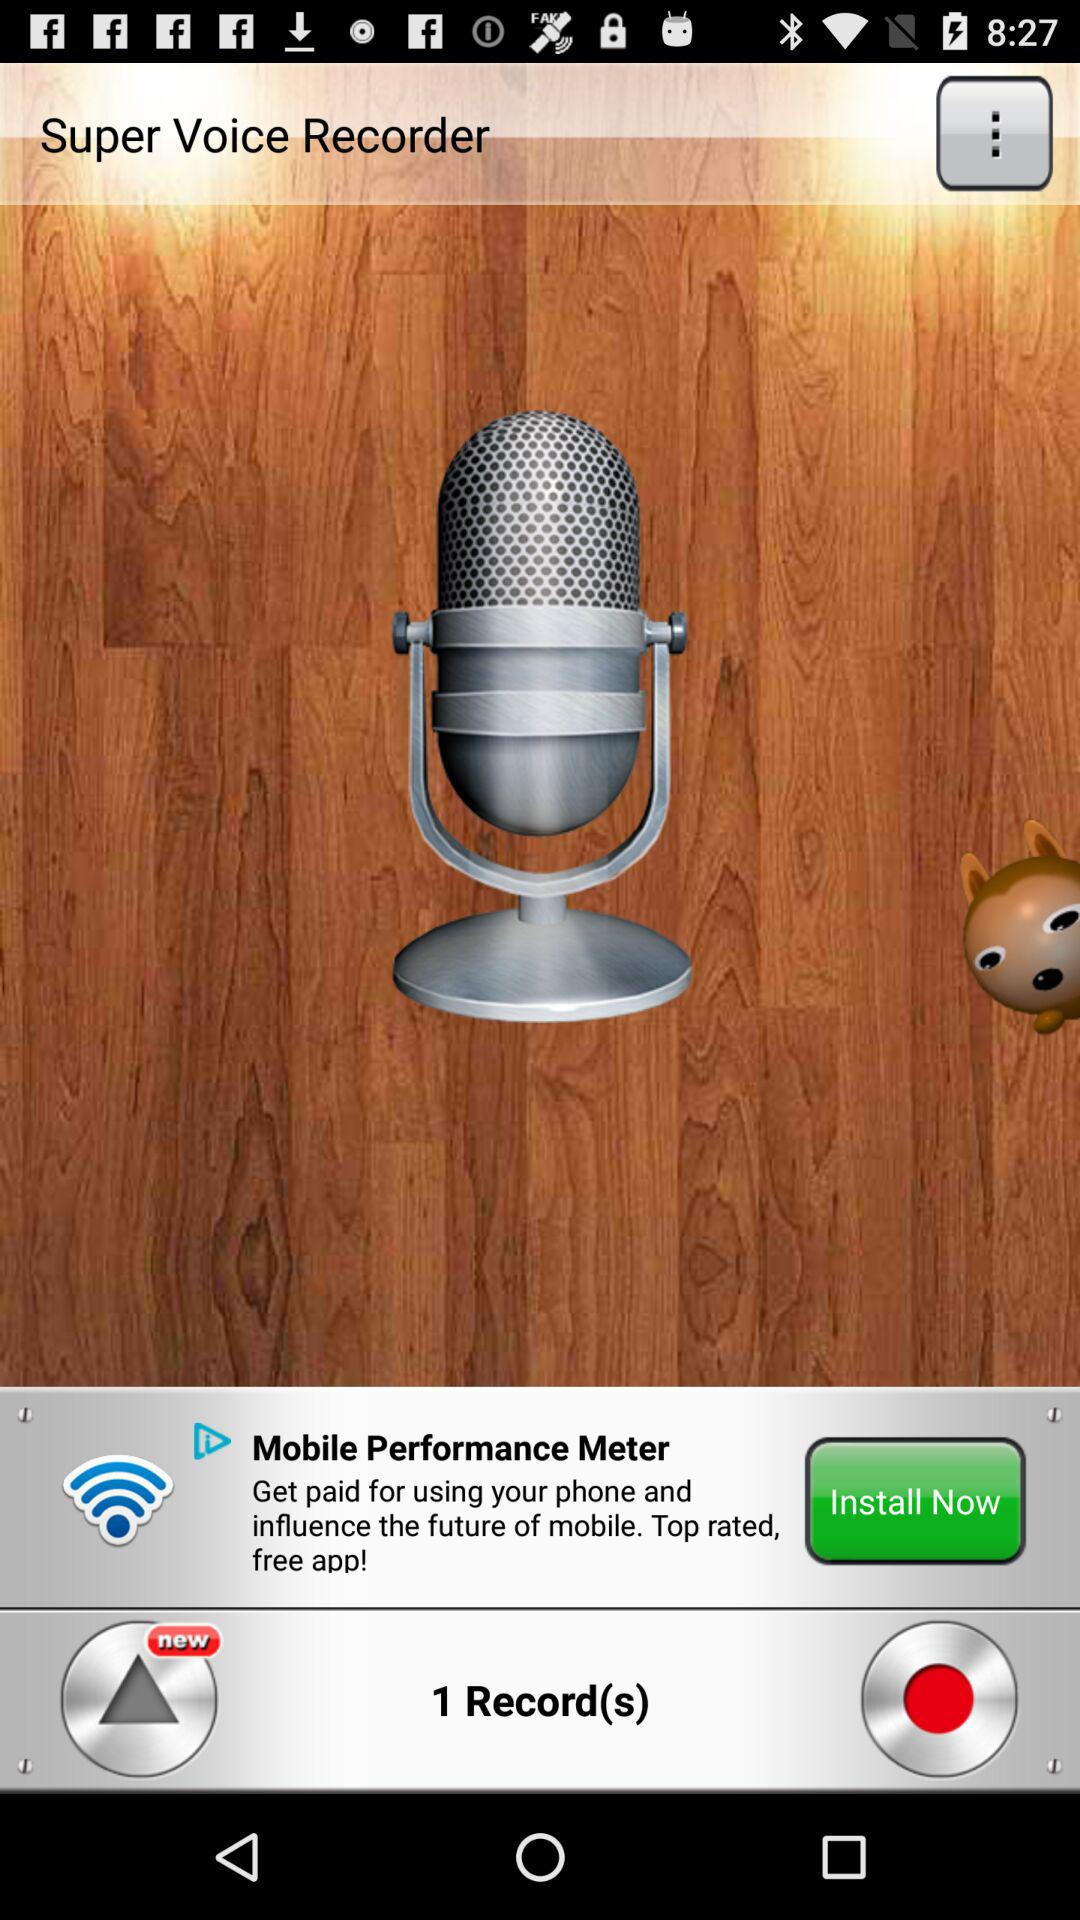How much will we get paid for using "Mobile Performance Meter"?
When the provided information is insufficient, respond with <no answer>. <no answer> 